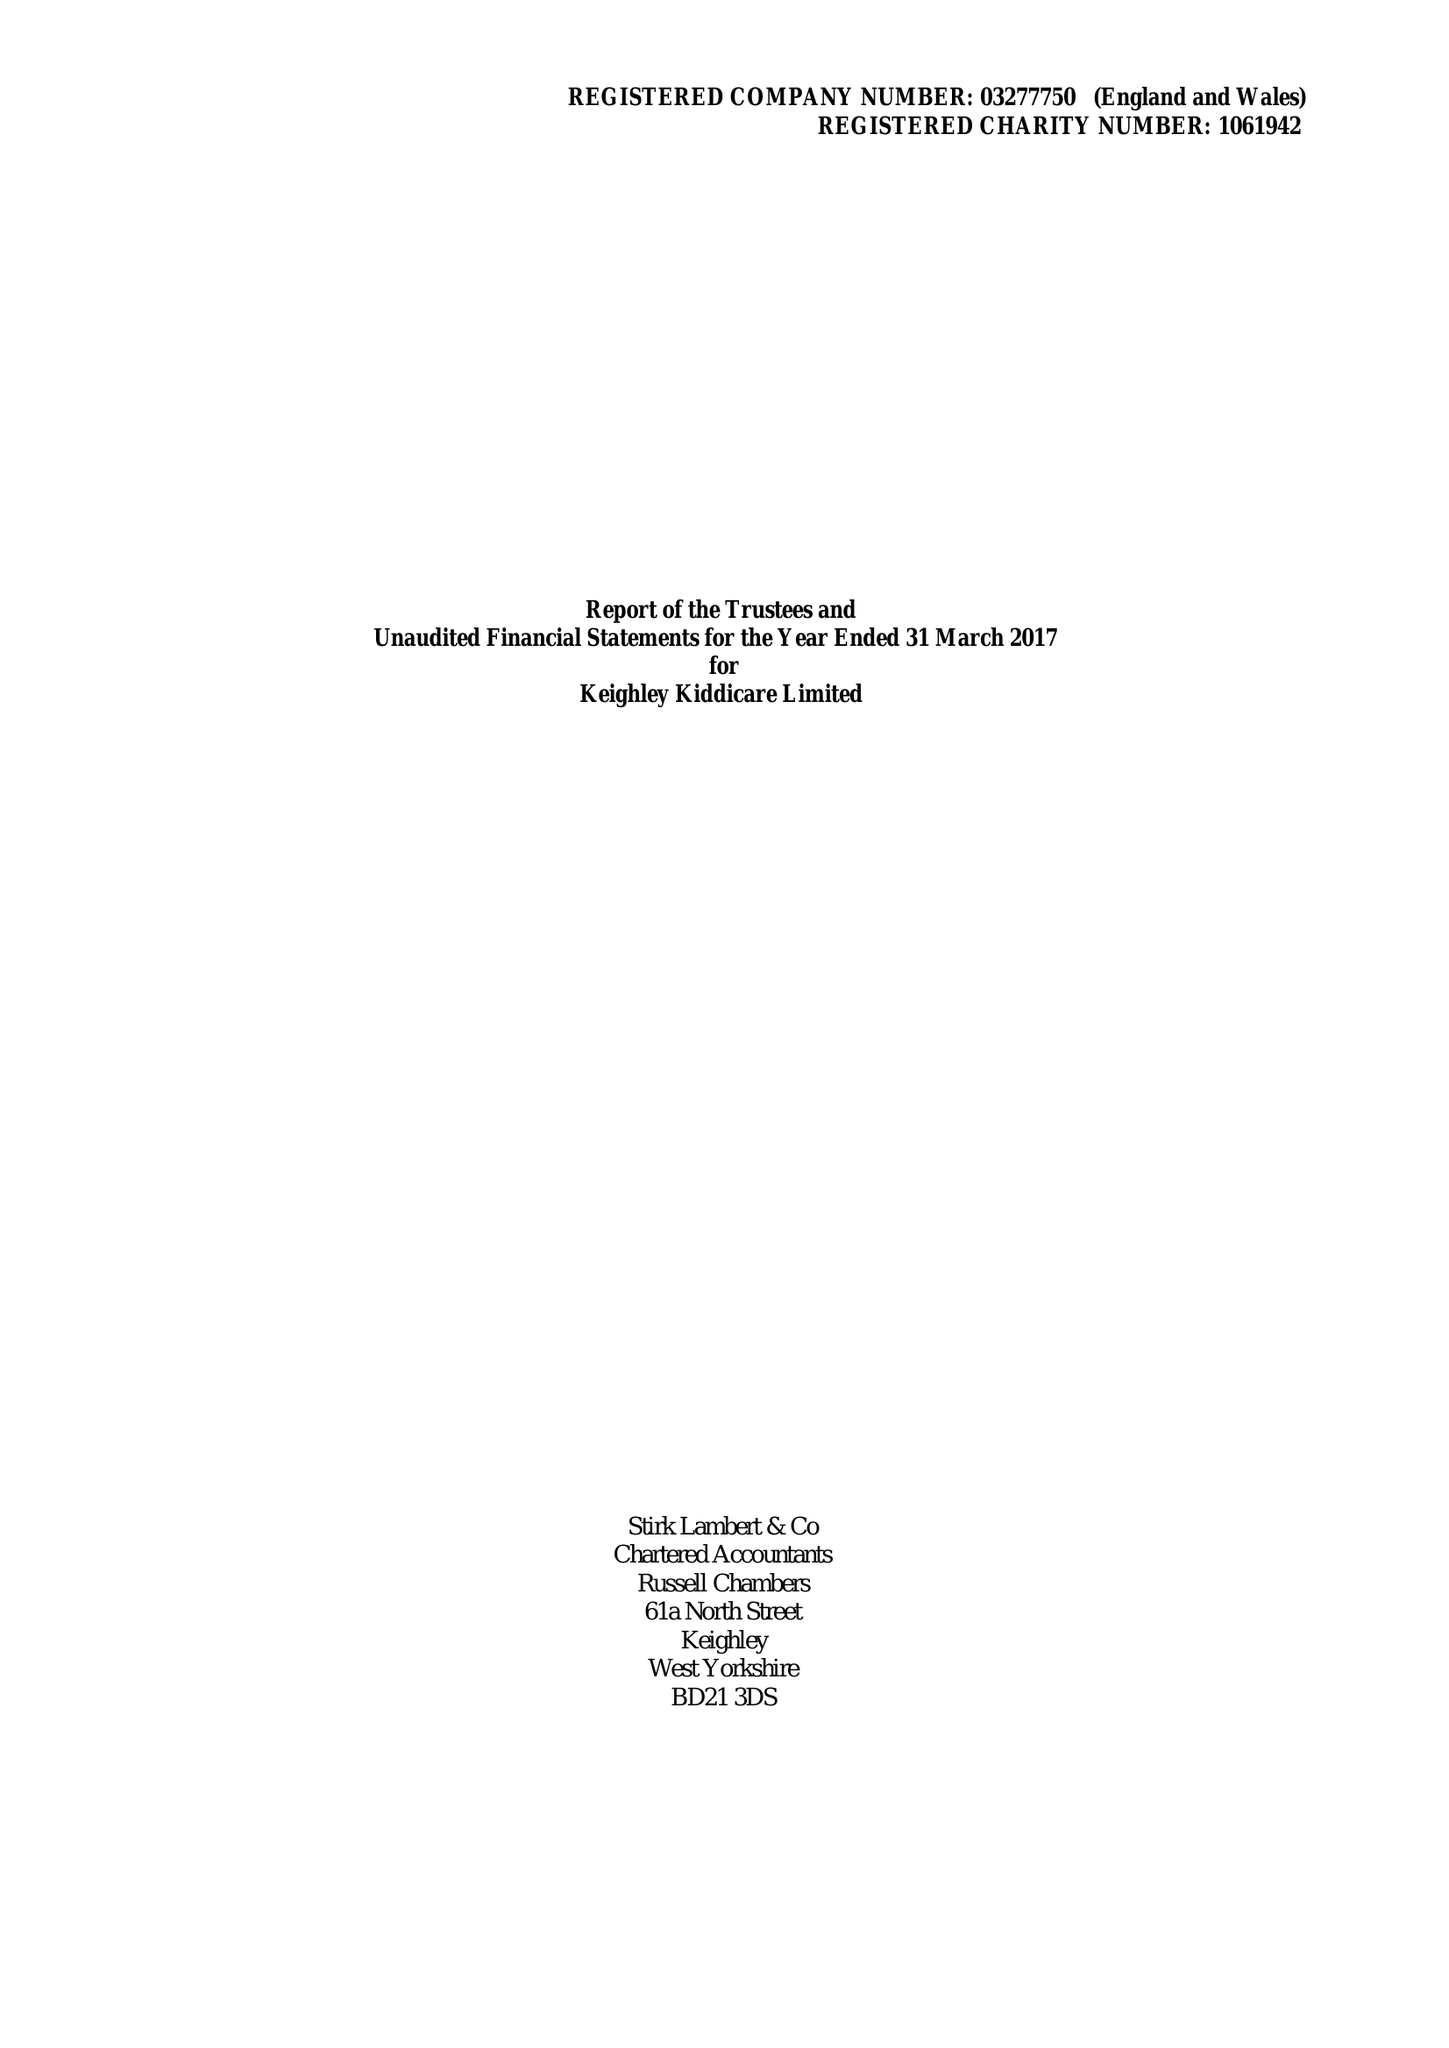What is the value for the address__postcode?
Answer the question using a single word or phrase. BD21 2EU 